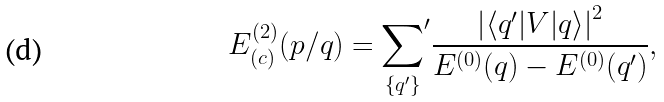Convert formula to latex. <formula><loc_0><loc_0><loc_500><loc_500>E _ { ( c ) } ^ { ( 2 ) } ( p / q ) = { \sum _ { \{ { q } ^ { \prime } \} } } ^ { \prime } \frac { \left | \langle { q } ^ { \prime } | V | { q } \rangle \right | ^ { 2 } } { E ^ { ( 0 ) } ( { q } ) - E ^ { ( 0 ) } ( { q } ^ { \prime } ) } ,</formula> 